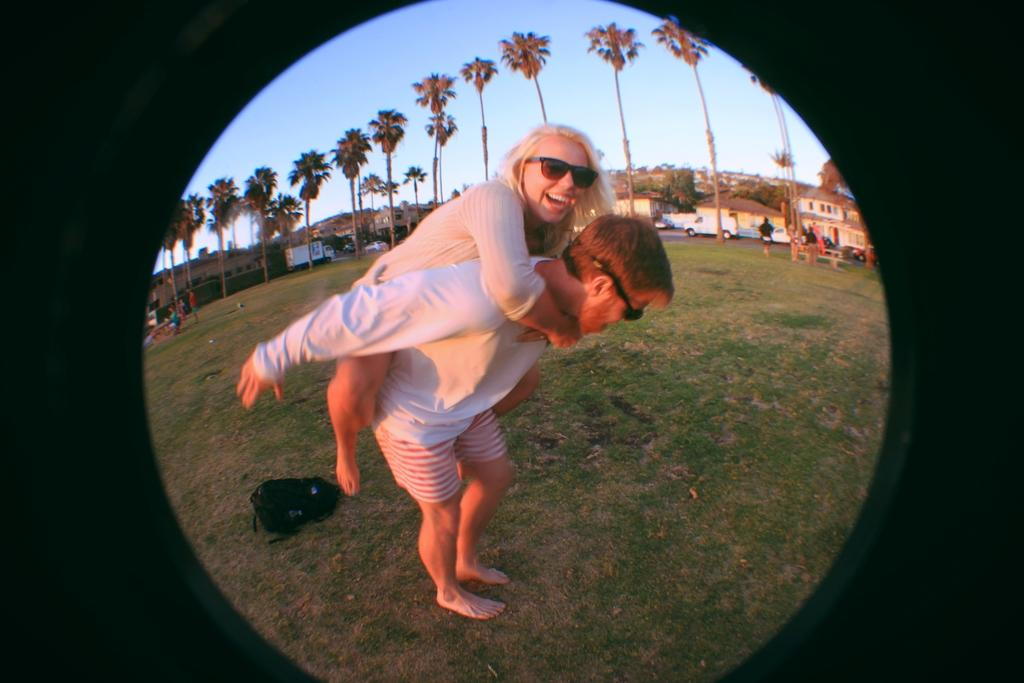What is happening between the two people in the image? There is a person holding a lady in the image. What can be seen in the distance behind the people? There are trees, houses, and vehicles on the road visible in the background of the image. What type of picture is hanging on the wall in the image? There is no picture hanging on the wall in the image. What date is marked on the calendar in the image? There is no calendar present in the image. 